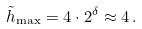Convert formula to latex. <formula><loc_0><loc_0><loc_500><loc_500>\tilde { h } _ { \max } = 4 \cdot 2 ^ { \delta } \approx 4 \, .</formula> 